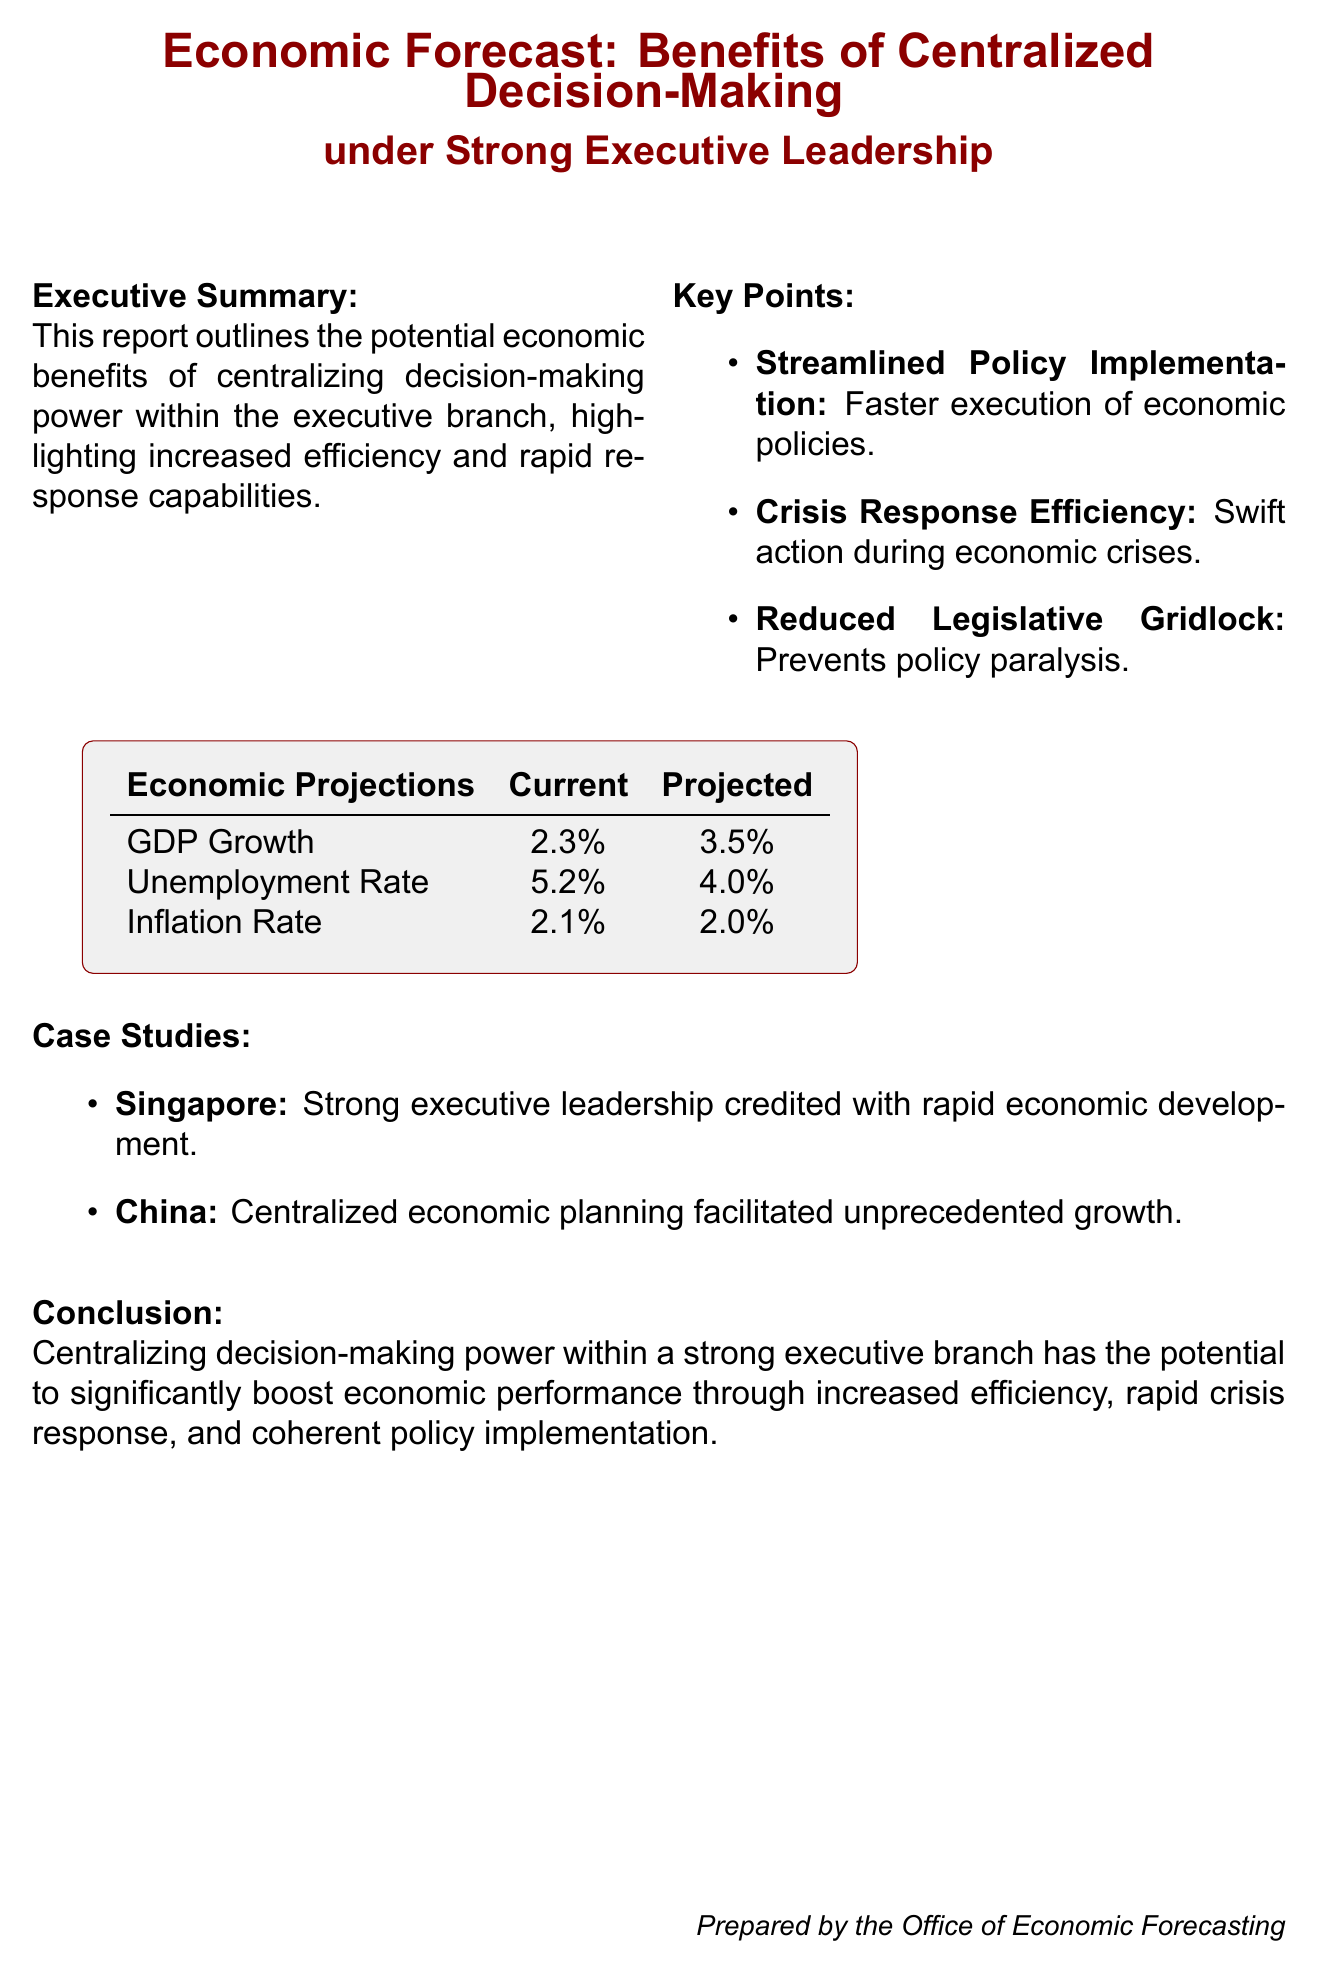What is the title of the report? The title of the report is stated at the beginning of the document, emphasizing the focus on centralized decision-making under executive leadership.
Answer: Economic Forecast: Benefits of Centralized Decision-Making under Strong Executive Leadership What is the current GDP growth rate? The current GDP growth rate is specified in the economic projections section of the document.
Answer: 2.3% What is the projected unemployment rate? The projected unemployment rate is listed under the economic projections, indicating future expectations.
Answer: 4.0% What case study features Singapore? The report includes case studies that highlight countries with strong executive leadership, including Singapore.
Answer: Singapore How does centralized decision-making affect crisis response? This question explores the reasoning behind the document's claims regarding the benefits of centralized authority during crises.
Answer: Swift What legislative issue does centralized decision-making help alleviate? The report mentions legislatures' challenges and how centralized decision-making can address these issues effectively.
Answer: Gridlock What economic condition is projected to decrease from current to projected values? The economic projections section of the document includes various metrics where some are expected to change, prompting this question.
Answer: Unemployment Rate What is the conclusion of the report? The conclusion summarizes the main arguments regarding executive power and economic performance.
Answer: Centralizing decision-making power within a strong executive branch has the potential to significantly boost economic performance 